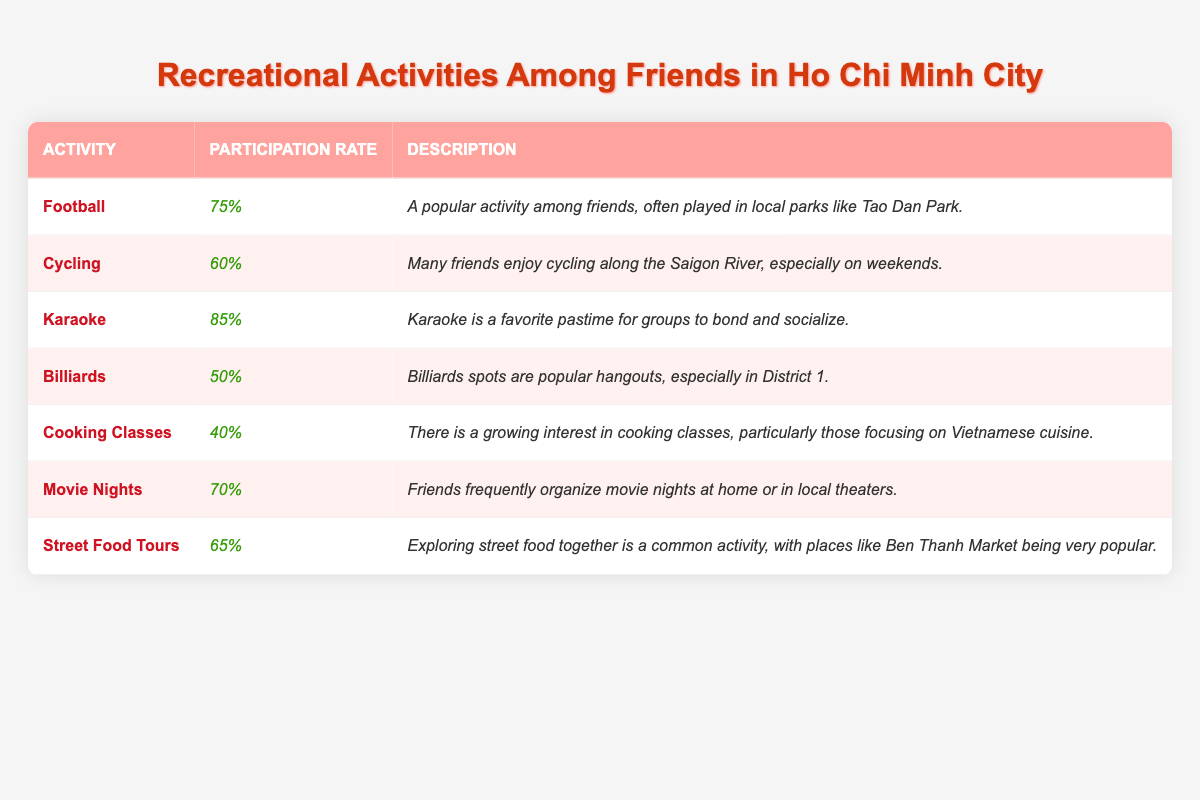What is the participation rate for Karaoke? The table shows that the participation rate for Karaoke is listed directly as "85%."
Answer: 85% Which activity has the highest participation rate? By looking at the participation rates, Karaoke has the highest rate at "85%."
Answer: Karaoke What percentage of friends participate in Billiards? The table indicates that 50% of friends participate in Billiards.
Answer: 50% How do the participation rates for Street Food Tours and Cooking Classes compare? The table shows that Street Food Tours have a participation rate of "65%", while Cooking Classes have "40%." Therefore, Street Food Tours have a higher rate by 25%.
Answer: Street Food Tours have a higher rate by 25% What is the average participation rate for all activities listed? To find the average, sum the participation rates: (75 + 60 + 85 + 50 + 40 + 70 + 65) = 445. Then, divide by the number of activities (7): 445/7 = 63.57%.
Answer: 63.57% Is the participation rate for Cycling above or below 65%? Cycling has a participation rate of "60%", which is below 65%.
Answer: Below Which activity has a participation rate lower than 60%? The activities listed are Billiards at "50%" and Cooking Classes at "40%," both of which are below 60%.
Answer: Billiards and Cooking Classes What can be inferred about the popularity of Karaoke among friends? With a high participation rate of "85%", Karaoke can be inferred to be very popular among friends for socializing and bonding.
Answer: Very popular What is the difference in participation rates between Football and Cycling? Football's rate is "75%" and Cycling's rate is "60%." The difference is 75% - 60% = 15%.
Answer: 15% If all friends participated in Football and Karaoke, what would the total percentage participation be? The participation is 75% for Football and 85% for Karaoke, but since this does not account for overlap or total unique participants, we should understand it's simply 75% + 85% without overlap considerations = 160%.
Answer: 160% (not unique) 